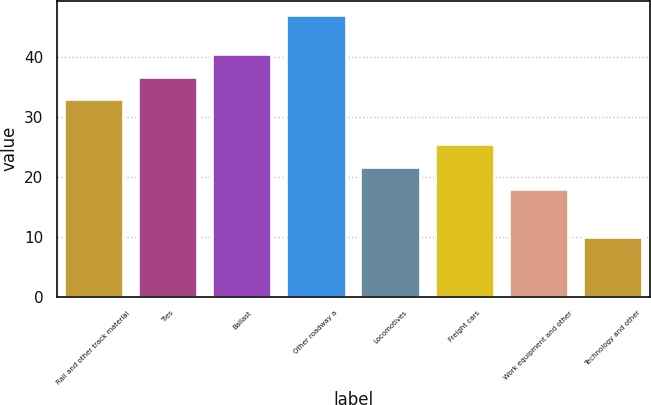Convert chart to OTSL. <chart><loc_0><loc_0><loc_500><loc_500><bar_chart><fcel>Rail and other track material<fcel>Ties<fcel>Ballast<fcel>Other roadway a<fcel>Locomotives<fcel>Freight cars<fcel>Work equipment and other<fcel>Technology and other<nl><fcel>33<fcel>36.7<fcel>40.4<fcel>47<fcel>21.7<fcel>25.4<fcel>18<fcel>10<nl></chart> 